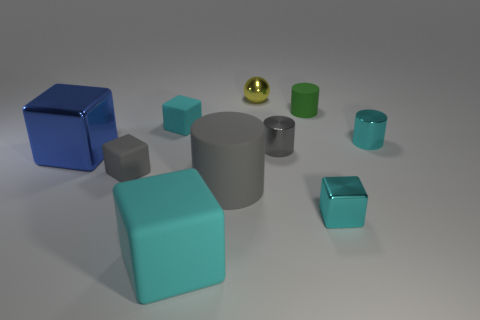There is a tiny cube that is the same color as the big matte cylinder; what is its material?
Keep it short and to the point. Rubber. What number of other things are the same shape as the tiny cyan matte thing?
Your answer should be compact. 4. Is the number of tiny gray matte things that are behind the small metal sphere less than the number of green matte objects in front of the cyan metallic cylinder?
Keep it short and to the point. No. Are the big gray object and the tiny cyan cube that is to the right of the green cylinder made of the same material?
Ensure brevity in your answer.  No. Are there more small metallic blocks than tiny yellow metal cubes?
Give a very brief answer. Yes. There is a tiny cyan shiny object to the left of the small cylinder to the right of the small cyan cube that is right of the small gray metallic cylinder; what shape is it?
Provide a succinct answer. Cube. Is the material of the big thing to the left of the big cyan object the same as the cyan cube behind the cyan shiny cylinder?
Provide a succinct answer. No. There is a big blue object that is made of the same material as the tiny yellow thing; what is its shape?
Your response must be concise. Cube. Is there any other thing that is the same color as the big rubber cylinder?
Your answer should be very brief. Yes. What number of tiny green shiny things are there?
Provide a succinct answer. 0. 